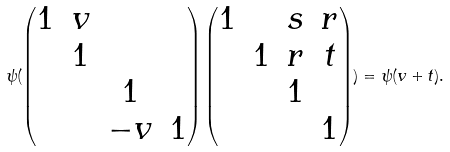Convert formula to latex. <formula><loc_0><loc_0><loc_500><loc_500>\psi ( \begin{pmatrix} 1 & v \\ & 1 \\ & & 1 \\ & & - v & 1 \end{pmatrix} \begin{pmatrix} 1 & & s & r \\ & 1 & r & t \\ & & 1 \\ & & & 1 \end{pmatrix} ) = \psi ( v + t ) .</formula> 